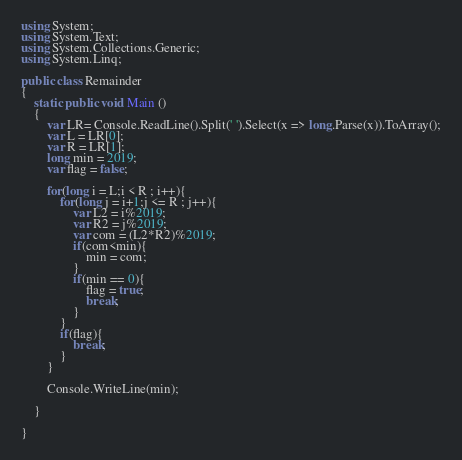<code> <loc_0><loc_0><loc_500><loc_500><_C#_>using System;
using System.Text; 
using System.Collections.Generic;
using System.Linq;

public class Remainder
{
    static public void Main ()
    {
        var LR= Console.ReadLine().Split(' ').Select(x => long.Parse(x)).ToArray();
        var L = LR[0];
        var R = LR[1];
        long min = 2019;
        var flag = false;
        
        for(long i = L;i < R ; i++){
            for(long j = i+1;j <= R ; j++){
                var L2 = i%2019;
                var R2 = j%2019;
                var com = (L2*R2)%2019;
                if(com<min){
                    min = com;
                }
                if(min == 0){
                    flag = true;
                    break;
                }                
            }
            if(flag){
                break;
            }
        }
        
        Console.WriteLine(min);

    }

}
</code> 